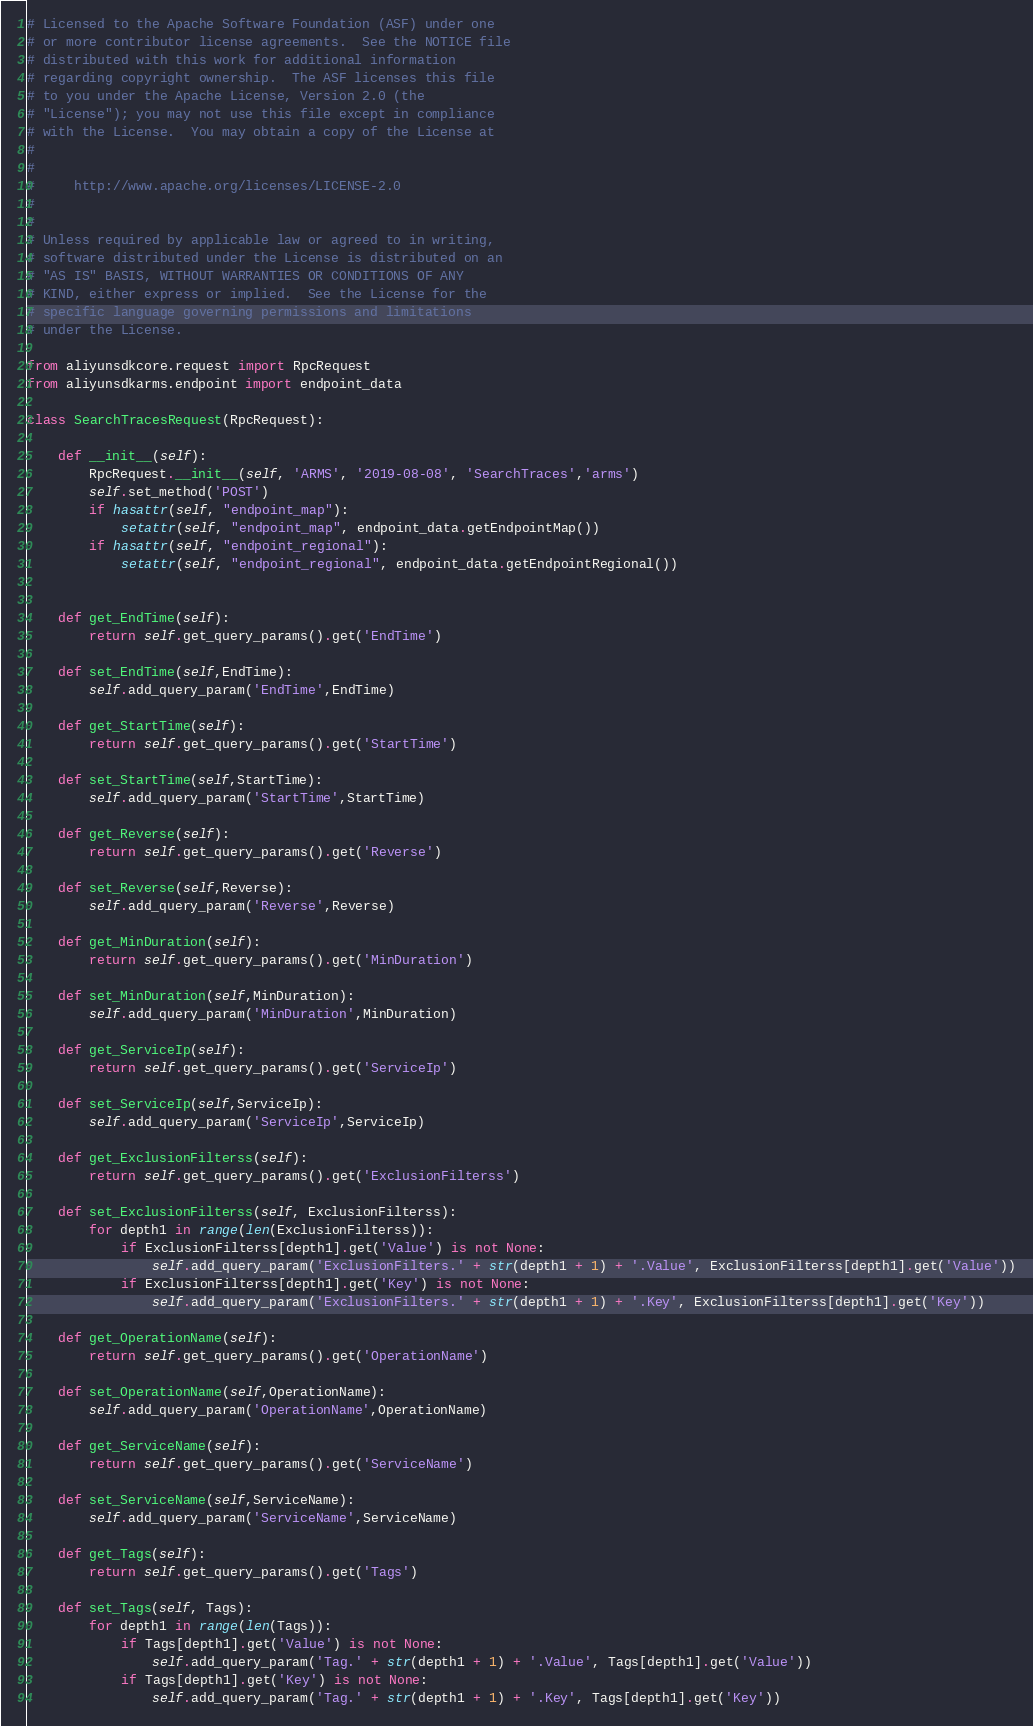<code> <loc_0><loc_0><loc_500><loc_500><_Python_># Licensed to the Apache Software Foundation (ASF) under one
# or more contributor license agreements.  See the NOTICE file
# distributed with this work for additional information
# regarding copyright ownership.  The ASF licenses this file
# to you under the Apache License, Version 2.0 (the
# "License"); you may not use this file except in compliance
# with the License.  You may obtain a copy of the License at
#
#
#     http://www.apache.org/licenses/LICENSE-2.0
#
#
# Unless required by applicable law or agreed to in writing,
# software distributed under the License is distributed on an
# "AS IS" BASIS, WITHOUT WARRANTIES OR CONDITIONS OF ANY
# KIND, either express or implied.  See the License for the
# specific language governing permissions and limitations
# under the License.

from aliyunsdkcore.request import RpcRequest
from aliyunsdkarms.endpoint import endpoint_data

class SearchTracesRequest(RpcRequest):

	def __init__(self):
		RpcRequest.__init__(self, 'ARMS', '2019-08-08', 'SearchTraces','arms')
		self.set_method('POST')
		if hasattr(self, "endpoint_map"):
			setattr(self, "endpoint_map", endpoint_data.getEndpointMap())
		if hasattr(self, "endpoint_regional"):
			setattr(self, "endpoint_regional", endpoint_data.getEndpointRegional())


	def get_EndTime(self):
		return self.get_query_params().get('EndTime')

	def set_EndTime(self,EndTime):
		self.add_query_param('EndTime',EndTime)

	def get_StartTime(self):
		return self.get_query_params().get('StartTime')

	def set_StartTime(self,StartTime):
		self.add_query_param('StartTime',StartTime)

	def get_Reverse(self):
		return self.get_query_params().get('Reverse')

	def set_Reverse(self,Reverse):
		self.add_query_param('Reverse',Reverse)

	def get_MinDuration(self):
		return self.get_query_params().get('MinDuration')

	def set_MinDuration(self,MinDuration):
		self.add_query_param('MinDuration',MinDuration)

	def get_ServiceIp(self):
		return self.get_query_params().get('ServiceIp')

	def set_ServiceIp(self,ServiceIp):
		self.add_query_param('ServiceIp',ServiceIp)

	def get_ExclusionFilterss(self):
		return self.get_query_params().get('ExclusionFilterss')

	def set_ExclusionFilterss(self, ExclusionFilterss):
		for depth1 in range(len(ExclusionFilterss)):
			if ExclusionFilterss[depth1].get('Value') is not None:
				self.add_query_param('ExclusionFilters.' + str(depth1 + 1) + '.Value', ExclusionFilterss[depth1].get('Value'))
			if ExclusionFilterss[depth1].get('Key') is not None:
				self.add_query_param('ExclusionFilters.' + str(depth1 + 1) + '.Key', ExclusionFilterss[depth1].get('Key'))

	def get_OperationName(self):
		return self.get_query_params().get('OperationName')

	def set_OperationName(self,OperationName):
		self.add_query_param('OperationName',OperationName)

	def get_ServiceName(self):
		return self.get_query_params().get('ServiceName')

	def set_ServiceName(self,ServiceName):
		self.add_query_param('ServiceName',ServiceName)

	def get_Tags(self):
		return self.get_query_params().get('Tags')

	def set_Tags(self, Tags):
		for depth1 in range(len(Tags)):
			if Tags[depth1].get('Value') is not None:
				self.add_query_param('Tag.' + str(depth1 + 1) + '.Value', Tags[depth1].get('Value'))
			if Tags[depth1].get('Key') is not None:
				self.add_query_param('Tag.' + str(depth1 + 1) + '.Key', Tags[depth1].get('Key'))</code> 